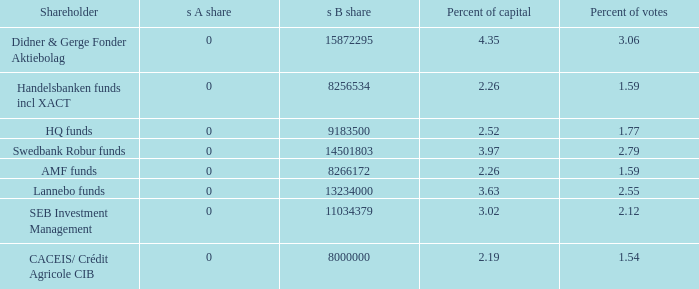What is the s B share for the shareholder that has 2.12 percent of votes?  11034379.0. 